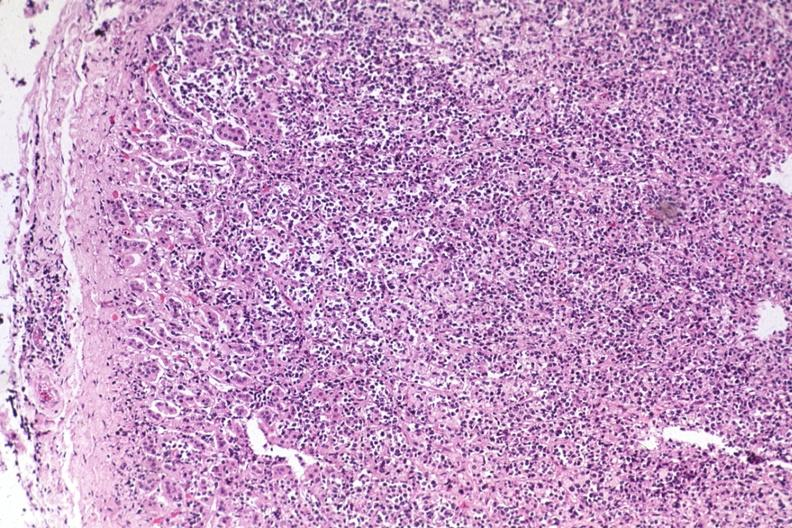s adrenal present?
Answer the question using a single word or phrase. Yes 